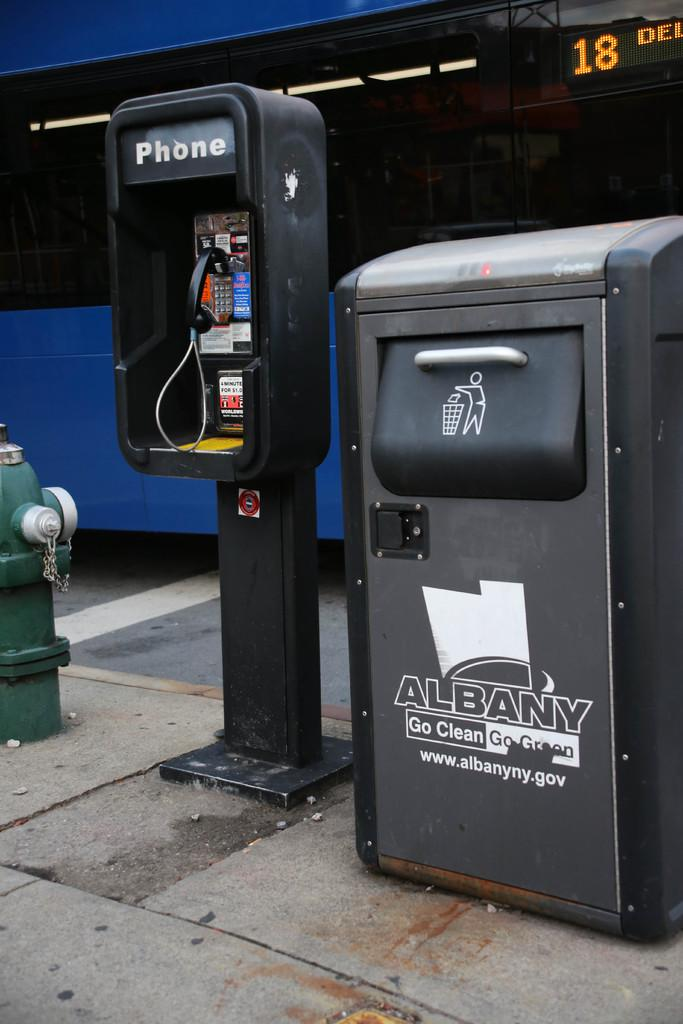<image>
Render a clear and concise summary of the photo. A trash bin that says Albany Go Clean  on it. 